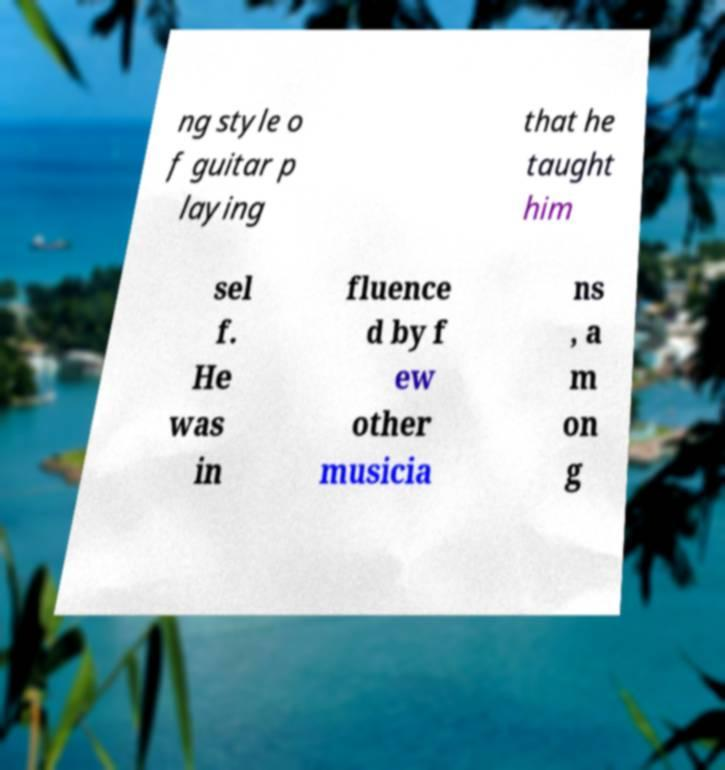What messages or text are displayed in this image? I need them in a readable, typed format. ng style o f guitar p laying that he taught him sel f. He was in fluence d by f ew other musicia ns , a m on g 